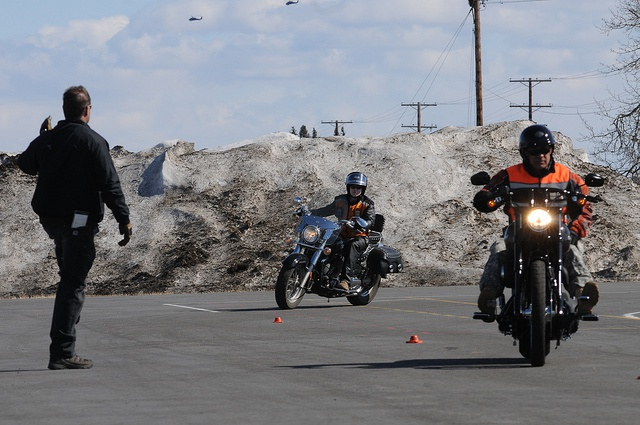Describe the objects in this image and their specific colors. I can see people in lightblue, black, and gray tones, motorcycle in lightblue, black, gray, maroon, and white tones, people in lightblue, black, gray, darkgray, and maroon tones, motorcycle in lightblue, black, gray, darkgray, and navy tones, and people in lightblue, black, gray, darkgray, and maroon tones in this image. 